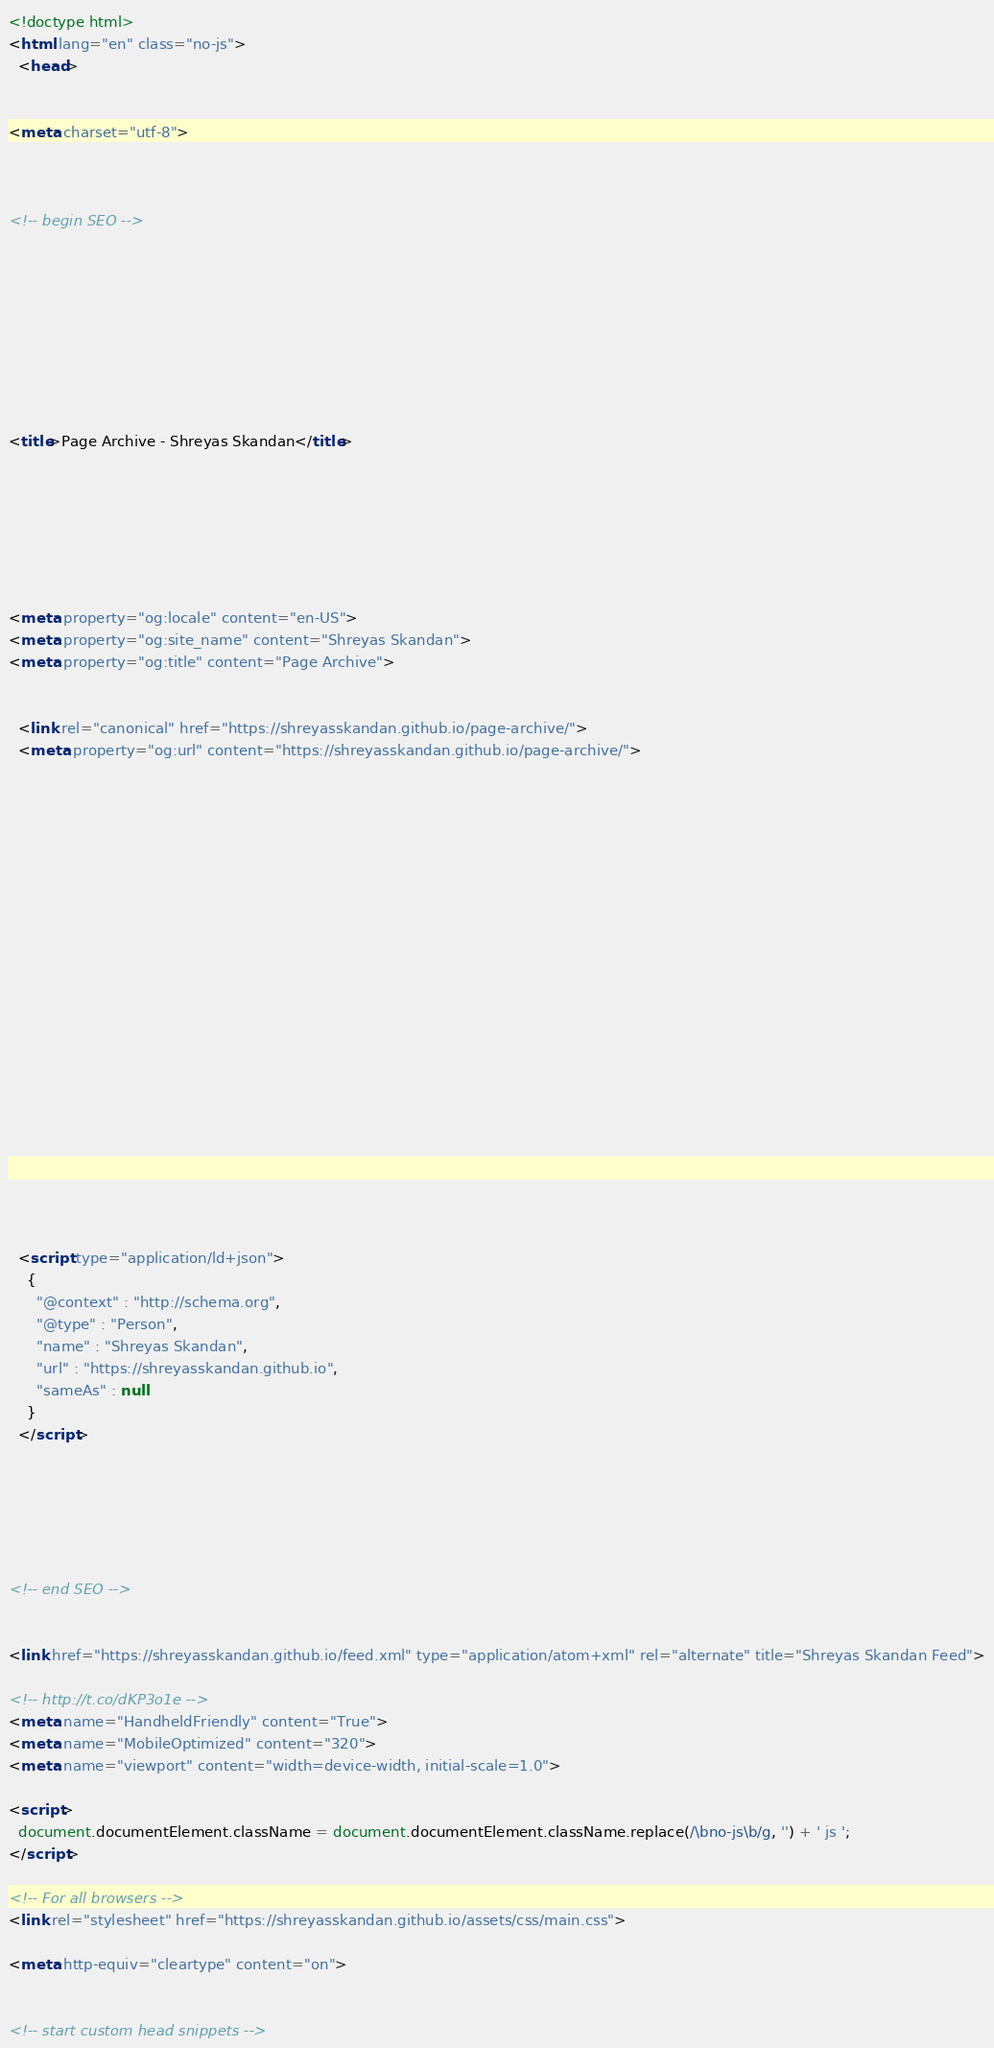Convert code to text. <code><loc_0><loc_0><loc_500><loc_500><_HTML_>

<!doctype html>
<html lang="en" class="no-js">
  <head>
    

<meta charset="utf-8">



<!-- begin SEO -->









<title>Page Archive - Shreyas Skandan</title>







<meta property="og:locale" content="en-US">
<meta property="og:site_name" content="Shreyas Skandan">
<meta property="og:title" content="Page Archive">


  <link rel="canonical" href="https://shreyasskandan.github.io/page-archive/">
  <meta property="og:url" content="https://shreyasskandan.github.io/page-archive/">







  

  












  <script type="application/ld+json">
    {
      "@context" : "http://schema.org",
      "@type" : "Person",
      "name" : "Shreyas Skandan",
      "url" : "https://shreyasskandan.github.io",
      "sameAs" : null
    }
  </script>






<!-- end SEO -->


<link href="https://shreyasskandan.github.io/feed.xml" type="application/atom+xml" rel="alternate" title="Shreyas Skandan Feed">

<!-- http://t.co/dKP3o1e -->
<meta name="HandheldFriendly" content="True">
<meta name="MobileOptimized" content="320">
<meta name="viewport" content="width=device-width, initial-scale=1.0">

<script>
  document.documentElement.className = document.documentElement.className.replace(/\bno-js\b/g, '') + ' js ';
</script>

<!-- For all browsers -->
<link rel="stylesheet" href="https://shreyasskandan.github.io/assets/css/main.css">

<meta http-equiv="cleartype" content="on">
    

<!-- start custom head snippets -->
</code> 